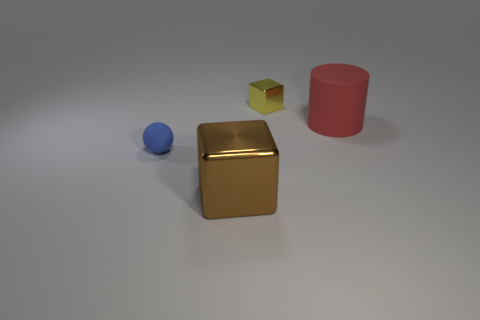Subtract all purple blocks. Subtract all yellow cylinders. How many blocks are left? 2 Subtract all yellow blocks. How many green cylinders are left? 0 Subtract all large purple metal objects. Subtract all large objects. How many objects are left? 2 Add 1 tiny yellow blocks. How many tiny yellow blocks are left? 2 Add 1 green shiny cubes. How many green shiny cubes exist? 1 Add 2 tiny blue rubber spheres. How many objects exist? 6 Subtract all yellow blocks. How many blocks are left? 1 Subtract 0 blue blocks. How many objects are left? 4 Subtract all cylinders. How many objects are left? 3 Subtract 1 cylinders. How many cylinders are left? 0 